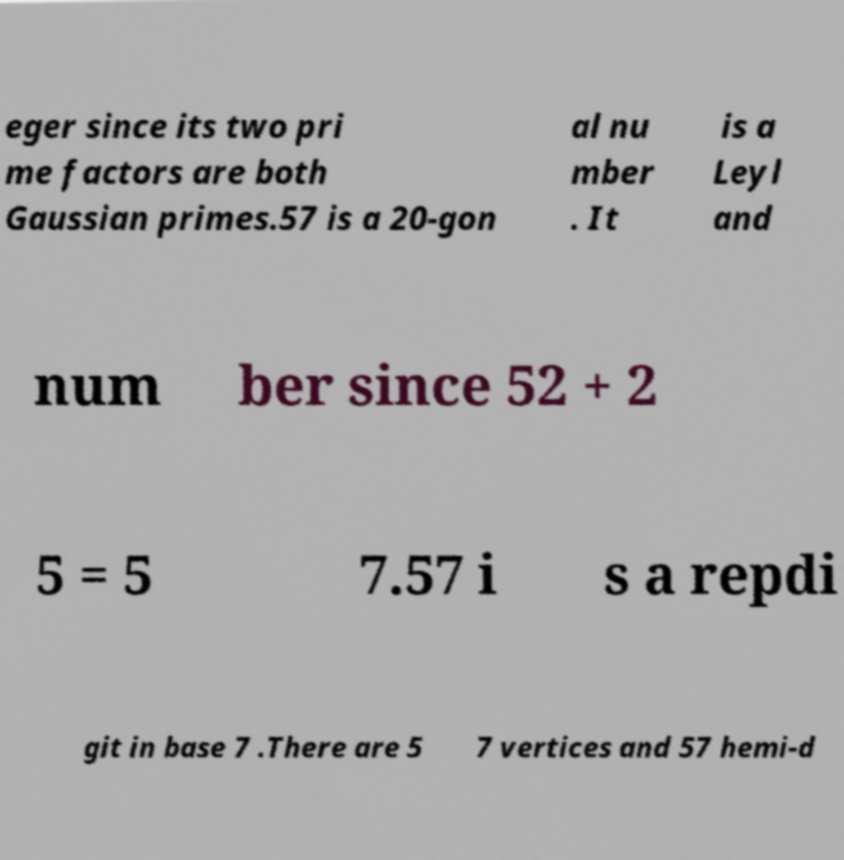Please read and relay the text visible in this image. What does it say? eger since its two pri me factors are both Gaussian primes.57 is a 20-gon al nu mber . It is a Leyl and num ber since 52 + 2 5 = 5 7.57 i s a repdi git in base 7 .There are 5 7 vertices and 57 hemi-d 